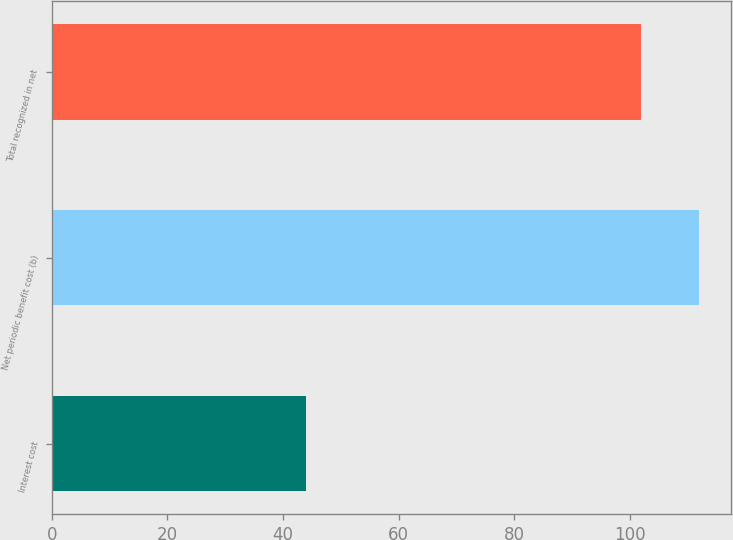Convert chart to OTSL. <chart><loc_0><loc_0><loc_500><loc_500><bar_chart><fcel>Interest cost<fcel>Net periodic benefit cost (b)<fcel>Total recognized in net<nl><fcel>44<fcel>112<fcel>102<nl></chart> 